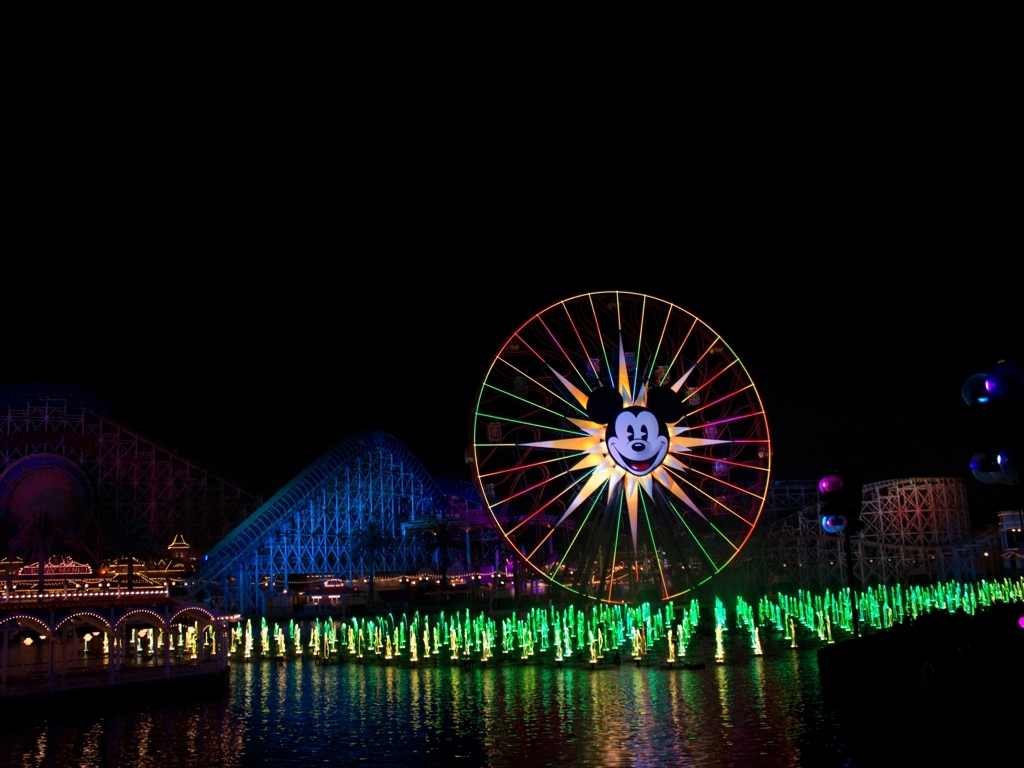How does the lighting affect the mood of this scene? The lighting plays a crucial role in creating a lively and enchanting ambiance. The bright, colorful lights against the dark background instill a sense of wonder and excitement, which is often associated with night-time festivities or amusement parks. Could you describe the color palette used in this image? Certainly! The image features a vivid color palette with a dominance of neon greens from the fountains, stark blues on the rollercoaster structure, and a spectrum of hues radiating from the Ferris wheel. The lights provide stark, vibrant contrasts to the otherwise dark setting, emphasizing the focal elements and creating visual depth. 